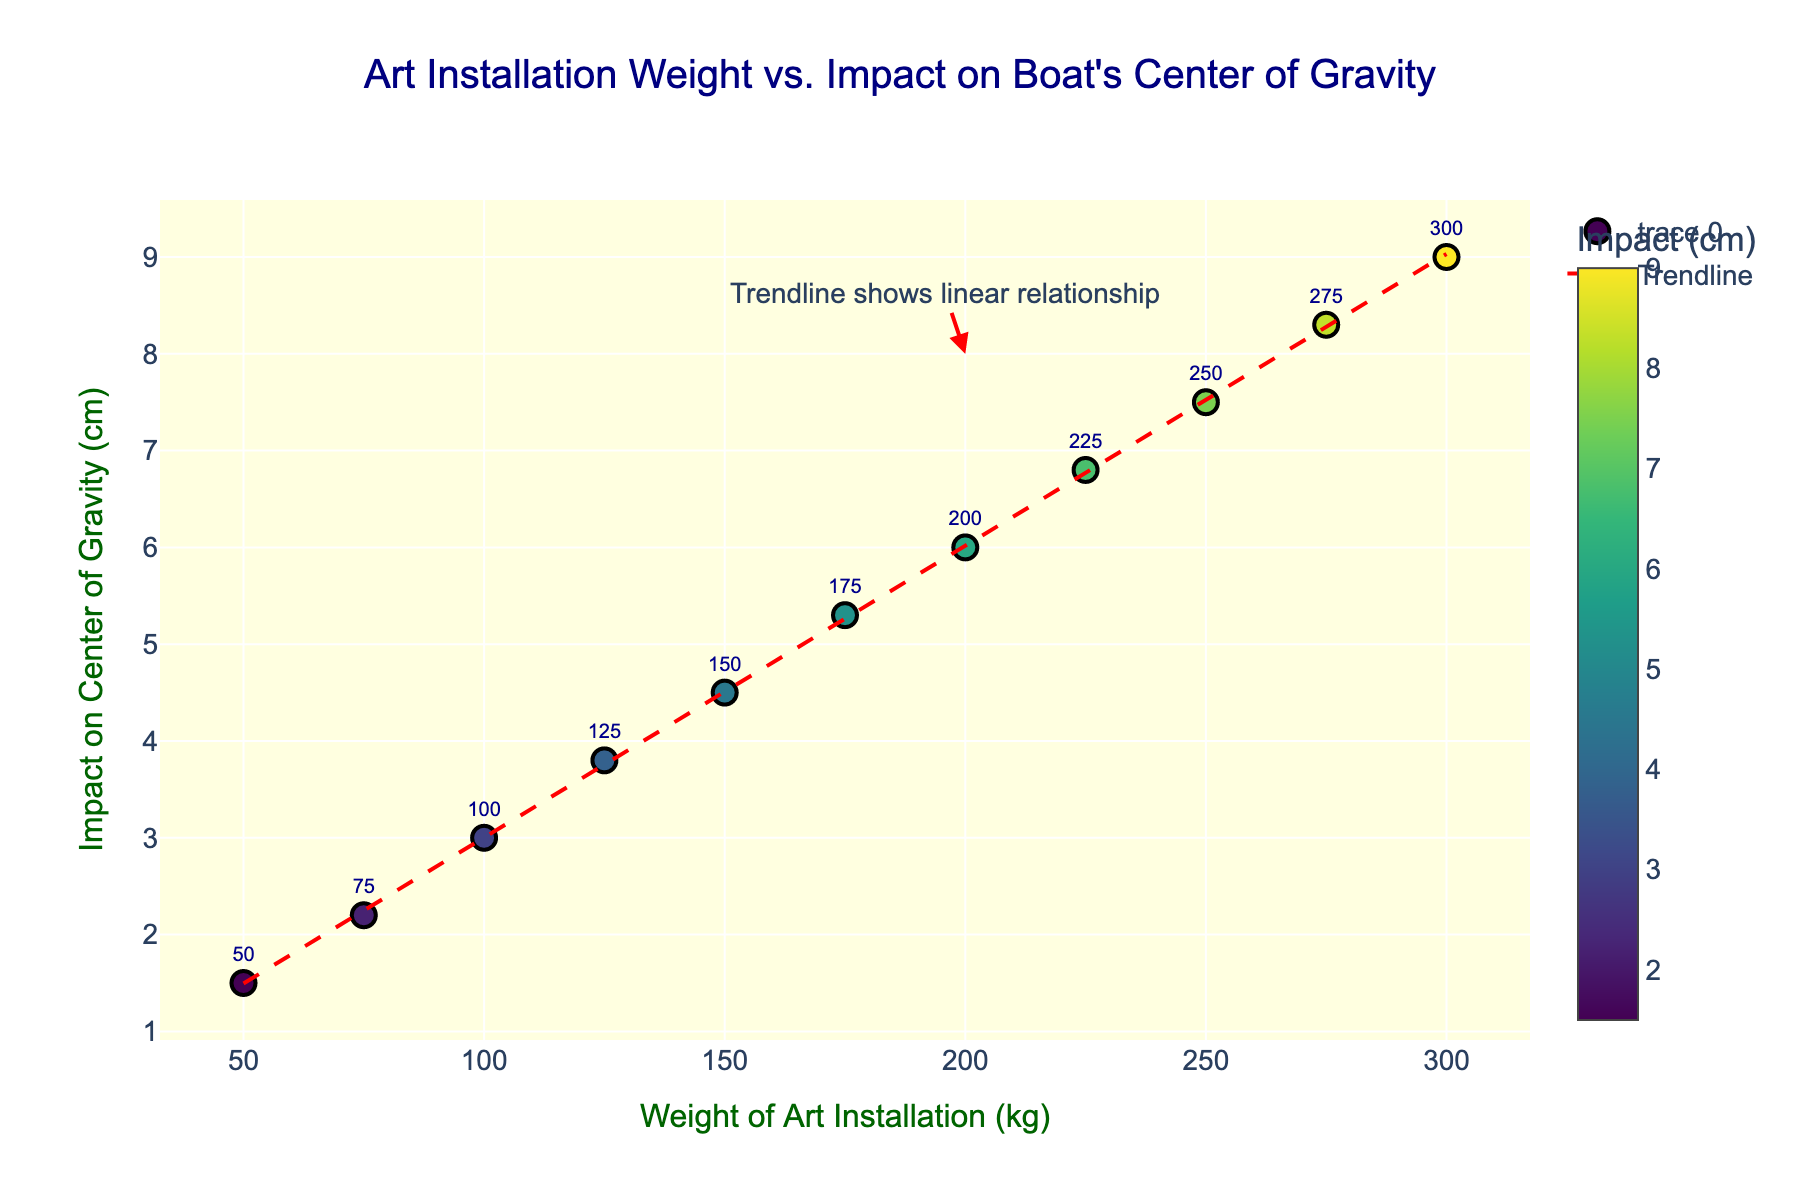How many data points are displayed on the scatter plot? The scatter plot shows one point for each pair of values of "Weight of Art Installation (kg)" and "Impact on Center of Gravity (cm)". Counting these pairs will give us the total number of data points. There are 11 pairs of values provided in the data, so there are 11 data points.
Answer: 11 What is the color pattern used for the markers? The markers are colored using a colorscale. The colorscale used is 'Viridis', which means that the colors will range through shades that go from yellow to dark blue. This colorscale is shown alongside the data points.
Answer: Viridis ranging from yellow to dark blue What is the title of the scatter plot? The title of the scatter plot is written at the top center of the figure. It reads "Art Installation Weight vs. Impact on Boat's Center of Gravity".
Answer: Art Installation Weight vs. Impact on Boat's Center of Gravity What does the trendline in the scatter plot represent? The trendline in the scatter plot represents the general relationship between the weight of the art installations and their impact on the boat's center of gravity. It shows a linear relationship, indicating that as the weight of the art installations increases, the impact on the boat's center of gravity also increases in a linear fashion.
Answer: Linear relationship between weight and impact on center of gravity How does the impact on the center of gravity change with increasing weight of the art installations? By observing the scatter plot, we can see that as the weight of the art installations increases, the impact on the center of gravity also increases. This is indicated by the upward trend of the data points and is confirmed by the trendline.
Answer: Increases At what weight does the trendline annotation point to? The trendline annotation points to a weight value, which can be read from the x-axis where the annotation arrow is directed. The annotation points to the weight value of 200 kg.
Answer: 200 kg What is the range of impact on the center of gravity for the given weights? To find the range, we need to look at the smallest and largest values of the "Impact on Center of Gravity (cm)" on the y-axis. The smallest impact is 1.5 cm, and the largest is 9.0 cm. So the range is calculated by subtracting the smallest value from the largest value: 9.0 cm - 1.5 cm = 7.5 cm.
Answer: 7.5 cm Between which weights of art installations does the impact on the center of gravity increase the most? To determine this, we need to find the interval with the largest difference in the "Impact on Center of Gravity (cm)". By comparing the differences between consecutive weights, the largest increase is between 75 kg (impact 2.2 cm) and 100 kg (impact 3.0 cm), which is (3.0 cm - 2.2 cm) = 0.8 cm.
Answer: 75 kg to 100 kg Which data point has the highest impact on the center of gravity, and what is its corresponding weight? The highest impact on the center of gravity can be identified by looking at the y-axis for the maximum value. The maximum value is 9.0 cm and its corresponding weight is 300 kg.
Answer: 9.0 cm, 300 kg 